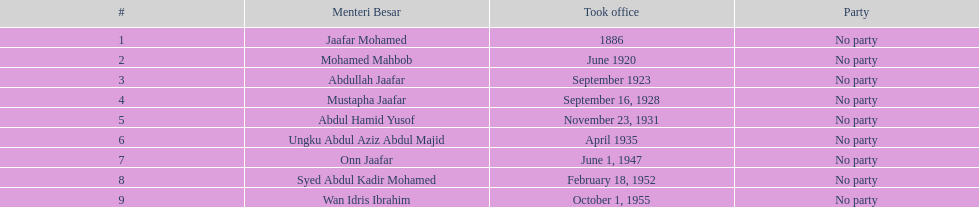What is the number of menteri besar that served 4 or more years? 3. 